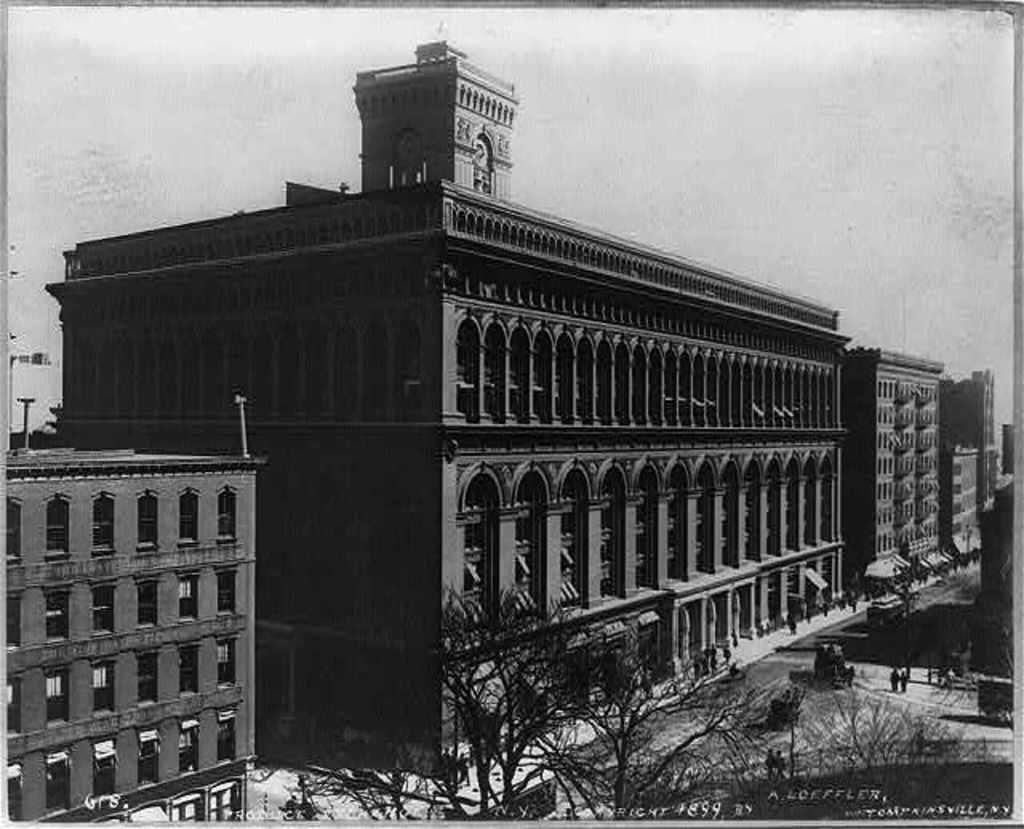What is the main structure in the image? There is a big building in the image. What type of natural elements can be seen in the image? There are trees in the image. What are the people in the image doing? The people are standing on the road in the image. What language is being spoken by the people in the image? There is no information about the language being spoken by the people in the image. How many clocks can be seen in the image? There is no mention of clocks in the image. 